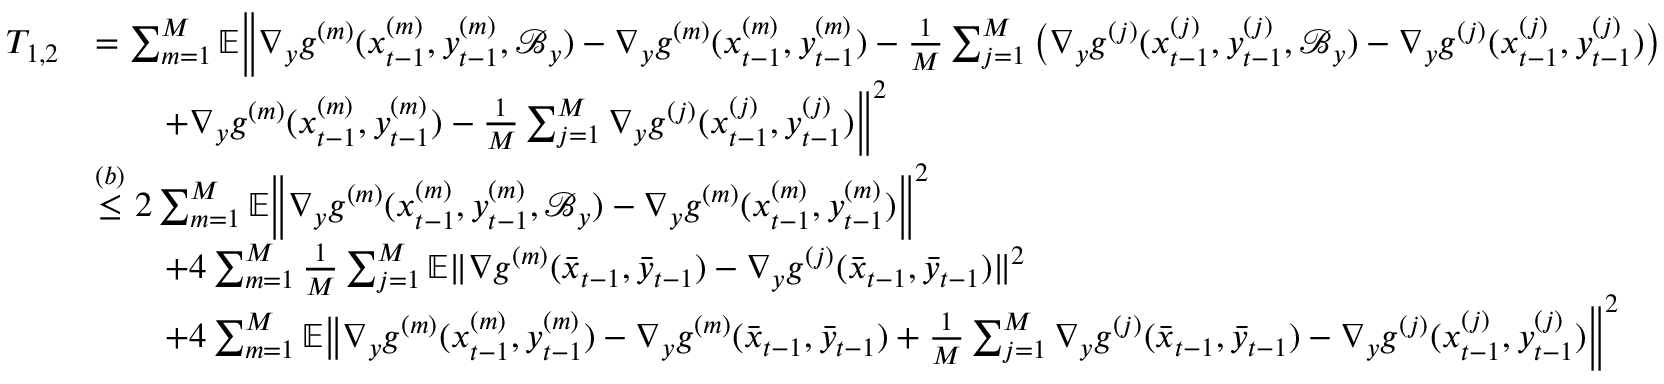<formula> <loc_0><loc_0><loc_500><loc_500>\begin{array} { r l } { T _ { 1 , 2 } } & { = \sum _ { m = 1 } ^ { M } \mathbb { E } \left \| \nabla _ { y } g ^ { ( m ) } ( x _ { t - 1 } ^ { ( m ) } , y _ { t - 1 } ^ { ( m ) } , \mathcal { B } _ { y } ) - \nabla _ { y } g ^ { ( m ) } ( x _ { t - 1 } ^ { ( m ) } , y _ { t - 1 } ^ { ( m ) } ) - \frac { 1 } { M } \sum _ { j = 1 } ^ { M } \left ( \nabla _ { y } g ^ { ( j ) } ( x _ { t - 1 } ^ { ( j ) } , y _ { t - 1 } ^ { ( j ) } , \mathcal { B } _ { y } ) - \nabla _ { y } g ^ { ( j ) } ( x _ { t - 1 } ^ { ( j ) } , y _ { t - 1 } ^ { ( j ) } ) \right ) } \\ & { \quad + \nabla _ { y } g ^ { ( m ) } ( x _ { t - 1 } ^ { ( m ) } , y _ { t - 1 } ^ { ( m ) } ) - \frac { 1 } { M } \sum _ { j = 1 } ^ { M } \nabla _ { y } g ^ { ( j ) } ( x _ { t - 1 } ^ { ( j ) } , y _ { t - 1 } ^ { ( j ) } ) \right \| ^ { 2 } } \\ & { \overset { ( b ) } { \leq } 2 \sum _ { m = 1 } ^ { M } \mathbb { E } \left \| \nabla _ { y } g ^ { ( m ) } ( x _ { t - 1 } ^ { ( m ) } , y _ { t - 1 } ^ { ( m ) } , \mathcal { B } _ { y } ) - \nabla _ { y } g ^ { ( m ) } ( x _ { t - 1 } ^ { ( m ) } , y _ { t - 1 } ^ { ( m ) } ) \right \| ^ { 2 } } \\ & { \quad + 4 \sum _ { m = 1 } ^ { M } \frac { 1 } { M } \sum _ { j = 1 } ^ { M } \mathbb { E } \| \nabla g ^ { ( m ) } ( \bar { x } _ { t - 1 } , \bar { y } _ { t - 1 } ) - \nabla _ { y } g ^ { ( j ) } ( \bar { x } _ { t - 1 } , \bar { y } _ { t - 1 } ) \| ^ { 2 } } \\ & { \quad + 4 \sum _ { m = 1 } ^ { M } \mathbb { E } \left \| \nabla _ { y } g ^ { ( m ) } ( x _ { t - 1 } ^ { ( m ) } , y _ { t - 1 } ^ { ( m ) } ) - \nabla _ { y } g ^ { ( m ) } ( \bar { x } _ { t - 1 } , \bar { y } _ { t - 1 } ) + \frac { 1 } { M } \sum _ { j = 1 } ^ { M } \nabla _ { y } g ^ { ( j ) } ( \bar { x } _ { t - 1 } , \bar { y } _ { t - 1 } ) - \nabla _ { y } g ^ { ( j ) } ( x _ { t - 1 } ^ { ( j ) } , y _ { t - 1 } ^ { ( j ) } ) \right \| ^ { 2 } } \end{array}</formula> 